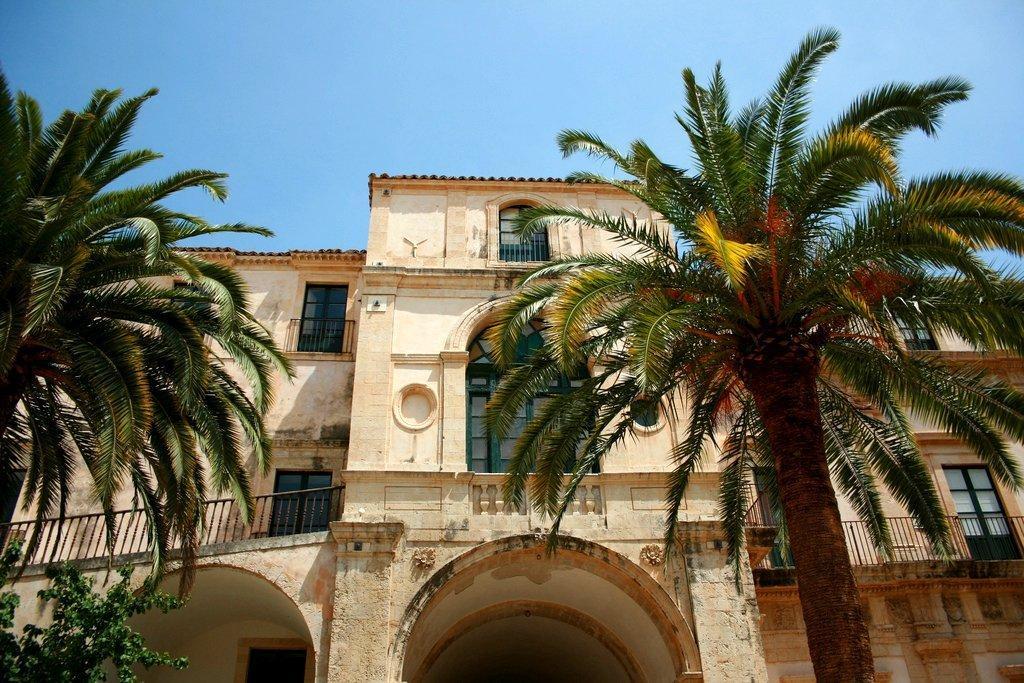Describe this image in one or two sentences. In the picture I can see a building which has few glass windows on it and there are few trees on either sides of it. 